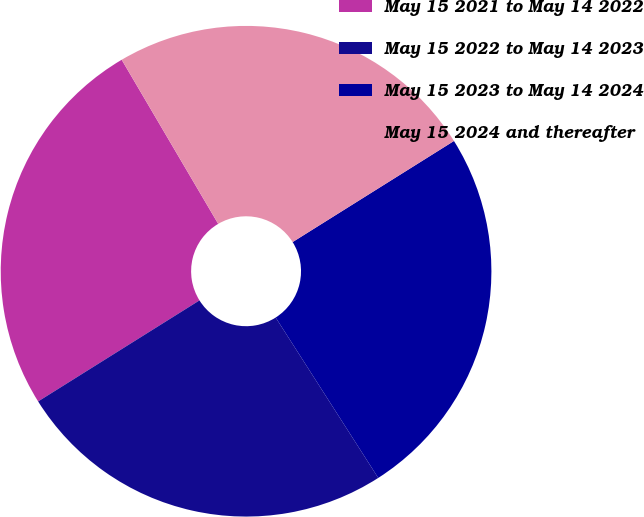<chart> <loc_0><loc_0><loc_500><loc_500><pie_chart><fcel>May 15 2021 to May 14 2022<fcel>May 15 2022 to May 14 2023<fcel>May 15 2023 to May 14 2024<fcel>May 15 2024 and thereafter<nl><fcel>25.44%<fcel>25.15%<fcel>24.85%<fcel>24.55%<nl></chart> 